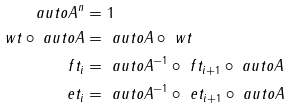<formula> <loc_0><loc_0><loc_500><loc_500>\ a u t o A ^ { n } & = 1 \\ \ w t \circ \ a u t o A & = \ a u t o A \circ \ w t \\ \ f t _ { i } & = \ a u t o A ^ { - 1 } \circ \ f t _ { i + 1 } \circ \ a u t o A \\ \ e t _ { i } & = \ a u t o A ^ { - 1 } \circ \ e t _ { i + 1 } \circ \ a u t o A</formula> 